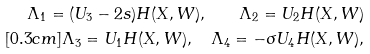<formula> <loc_0><loc_0><loc_500><loc_500>\Lambda _ { 1 } = ( U _ { 3 } - 2 s ) H ( X , W ) , \quad \Lambda _ { 2 } = U _ { 2 } H ( X , W ) \\ [ 0 . 3 c m ] \Lambda _ { 3 } = U _ { 1 } H ( X , W ) , \quad \Lambda _ { 4 } = - \sigma U _ { 4 } H ( X , W ) ,</formula> 